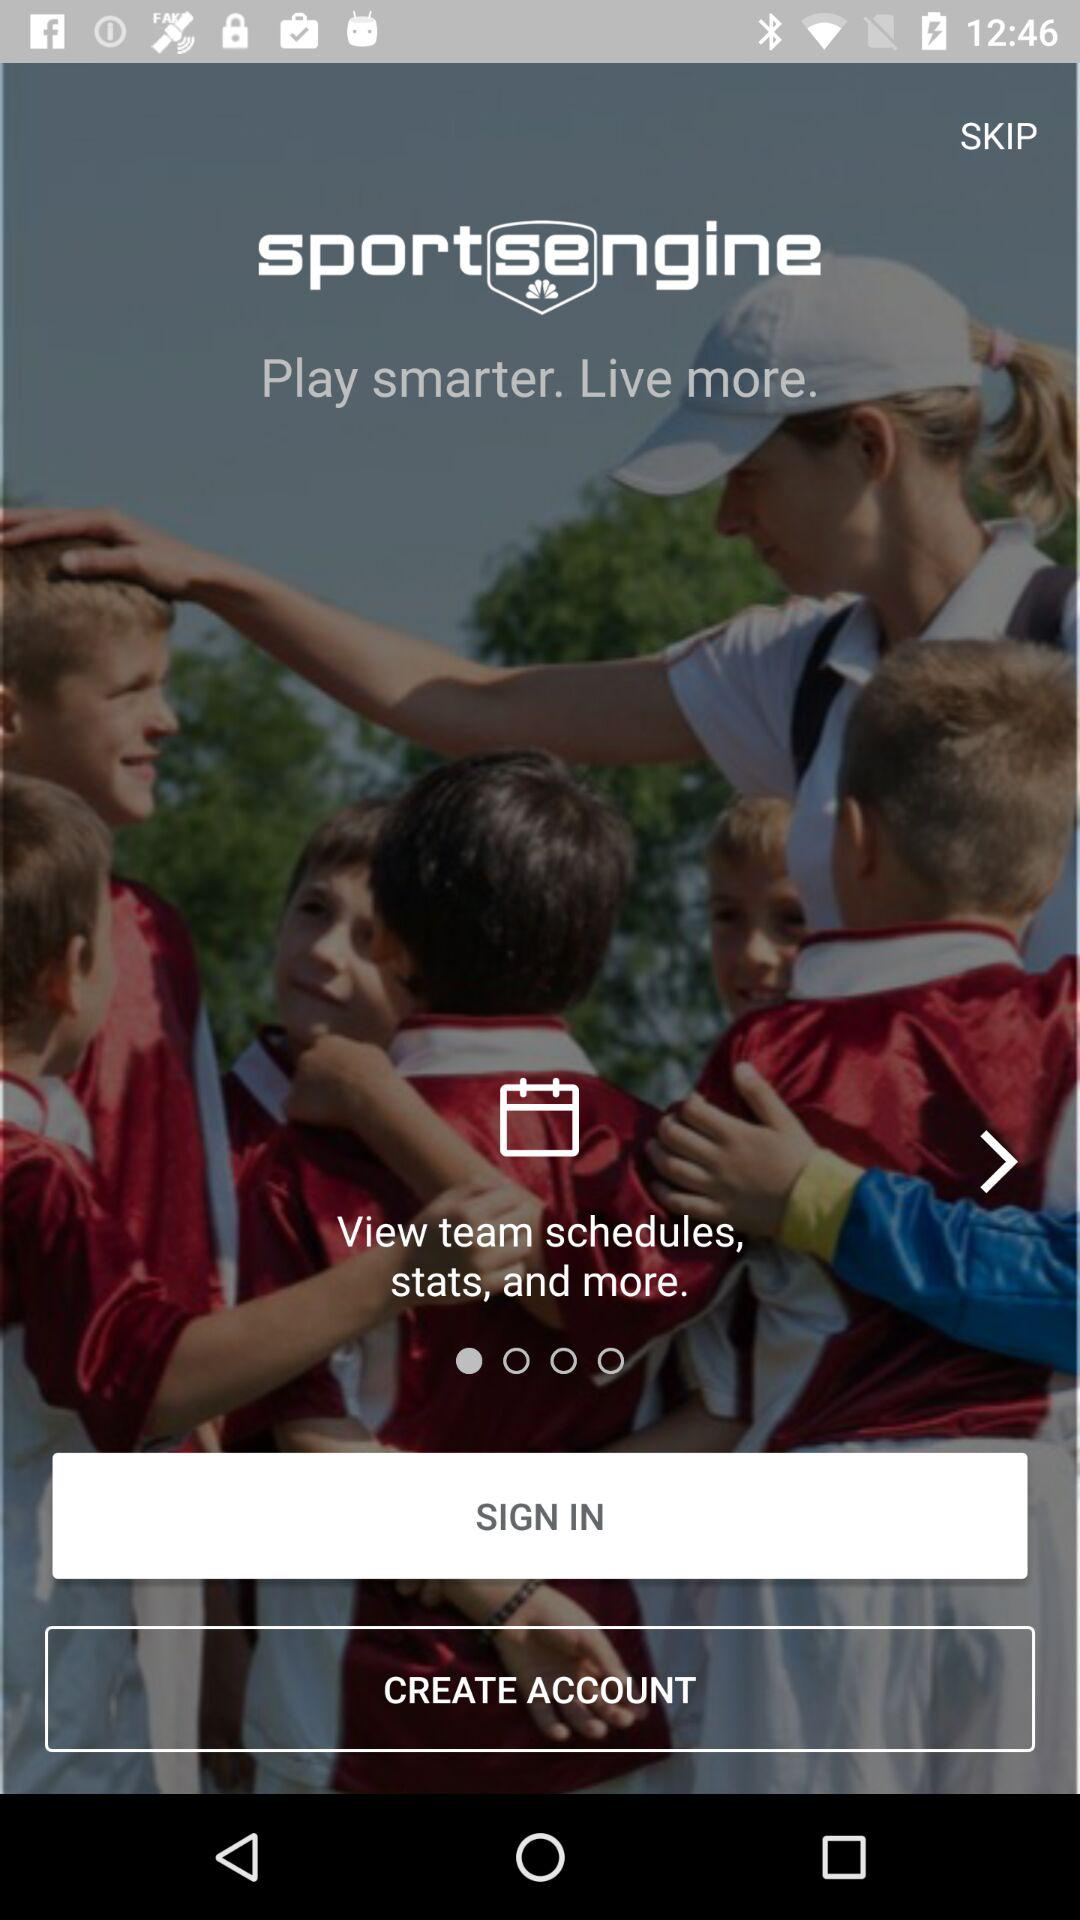What is the name of the application? The name of the application is "sportsengine". 